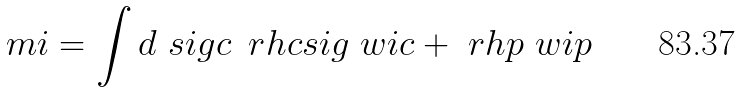<formula> <loc_0><loc_0><loc_500><loc_500>\ m i = \int d \ s i g c \, \ r h c s i g \ w i c + \ r h p \ w i p</formula> 